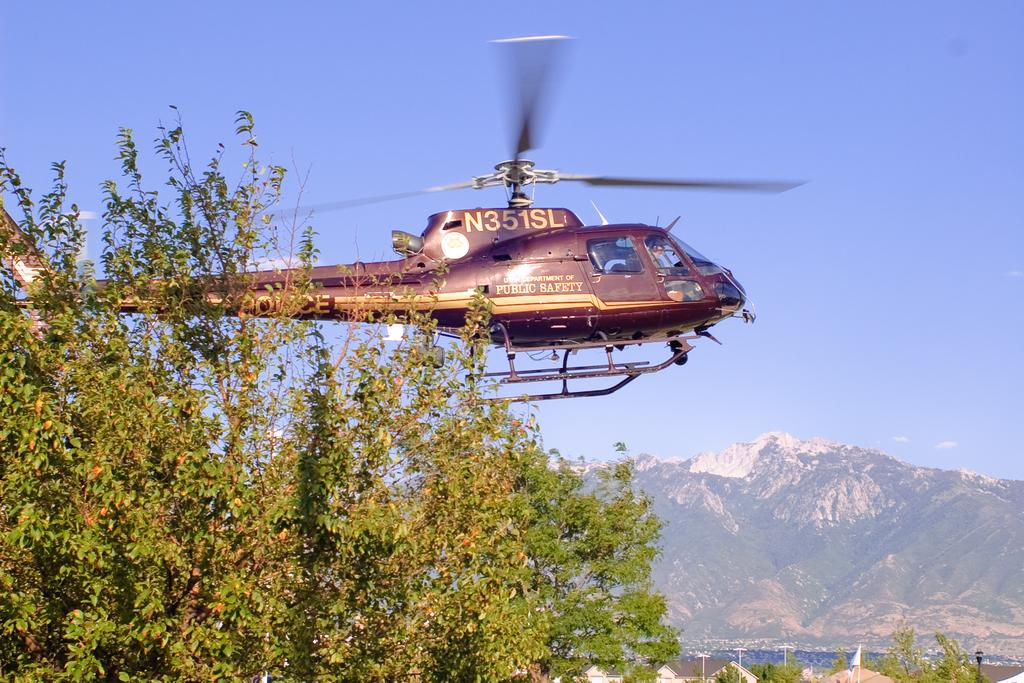<image>
Describe the image concisely. A helicopter from the Department of Public Safety has the tag number N351SL is flying over houses. 